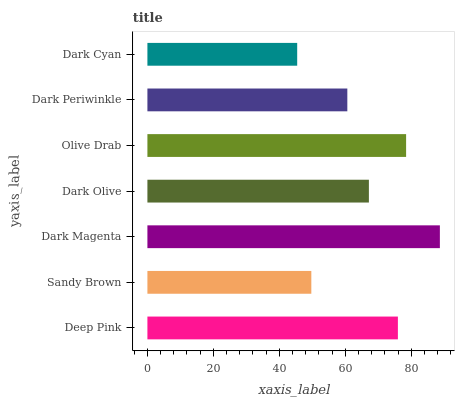Is Dark Cyan the minimum?
Answer yes or no. Yes. Is Dark Magenta the maximum?
Answer yes or no. Yes. Is Sandy Brown the minimum?
Answer yes or no. No. Is Sandy Brown the maximum?
Answer yes or no. No. Is Deep Pink greater than Sandy Brown?
Answer yes or no. Yes. Is Sandy Brown less than Deep Pink?
Answer yes or no. Yes. Is Sandy Brown greater than Deep Pink?
Answer yes or no. No. Is Deep Pink less than Sandy Brown?
Answer yes or no. No. Is Dark Olive the high median?
Answer yes or no. Yes. Is Dark Olive the low median?
Answer yes or no. Yes. Is Dark Magenta the high median?
Answer yes or no. No. Is Dark Magenta the low median?
Answer yes or no. No. 